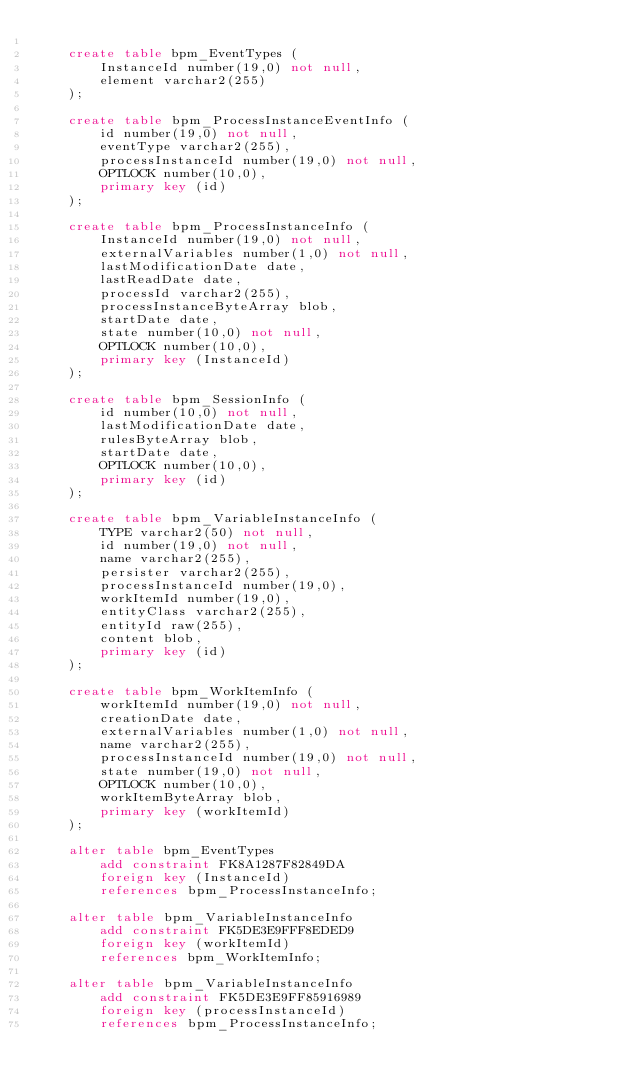Convert code to text. <code><loc_0><loc_0><loc_500><loc_500><_SQL_>
    create table bpm_EventTypes (
        InstanceId number(19,0) not null,
        element varchar2(255)
    );

    create table bpm_ProcessInstanceEventInfo (
        id number(19,0) not null,
        eventType varchar2(255),
        processInstanceId number(19,0) not null,
        OPTLOCK number(10,0),
        primary key (id)
    );

    create table bpm_ProcessInstanceInfo (
        InstanceId number(19,0) not null,
        externalVariables number(1,0) not null,
        lastModificationDate date,
        lastReadDate date,
        processId varchar2(255),
        processInstanceByteArray blob,
        startDate date,
        state number(10,0) not null,
        OPTLOCK number(10,0),
        primary key (InstanceId)
    );

    create table bpm_SessionInfo (
        id number(10,0) not null,
        lastModificationDate date,
        rulesByteArray blob,
        startDate date,
        OPTLOCK number(10,0),
        primary key (id)
    );

    create table bpm_VariableInstanceInfo (
        TYPE varchar2(50) not null,
        id number(19,0) not null,
        name varchar2(255),
        persister varchar2(255),
        processInstanceId number(19,0),
        workItemId number(19,0),
        entityClass varchar2(255),
        entityId raw(255),
        content blob,
        primary key (id)
    );

    create table bpm_WorkItemInfo (
        workItemId number(19,0) not null,
        creationDate date,
        externalVariables number(1,0) not null,
        name varchar2(255),
        processInstanceId number(19,0) not null,
        state number(19,0) not null,
        OPTLOCK number(10,0),
        workItemByteArray blob,
        primary key (workItemId)
    );

    alter table bpm_EventTypes 
        add constraint FK8A1287F82849DA 
        foreign key (InstanceId) 
        references bpm_ProcessInstanceInfo;

    alter table bpm_VariableInstanceInfo 
        add constraint FK5DE3E9FFF8EDED9 
        foreign key (workItemId) 
        references bpm_WorkItemInfo;

    alter table bpm_VariableInstanceInfo 
        add constraint FK5DE3E9FF85916989 
        foreign key (processInstanceId) 
        references bpm_ProcessInstanceInfo;

</code> 